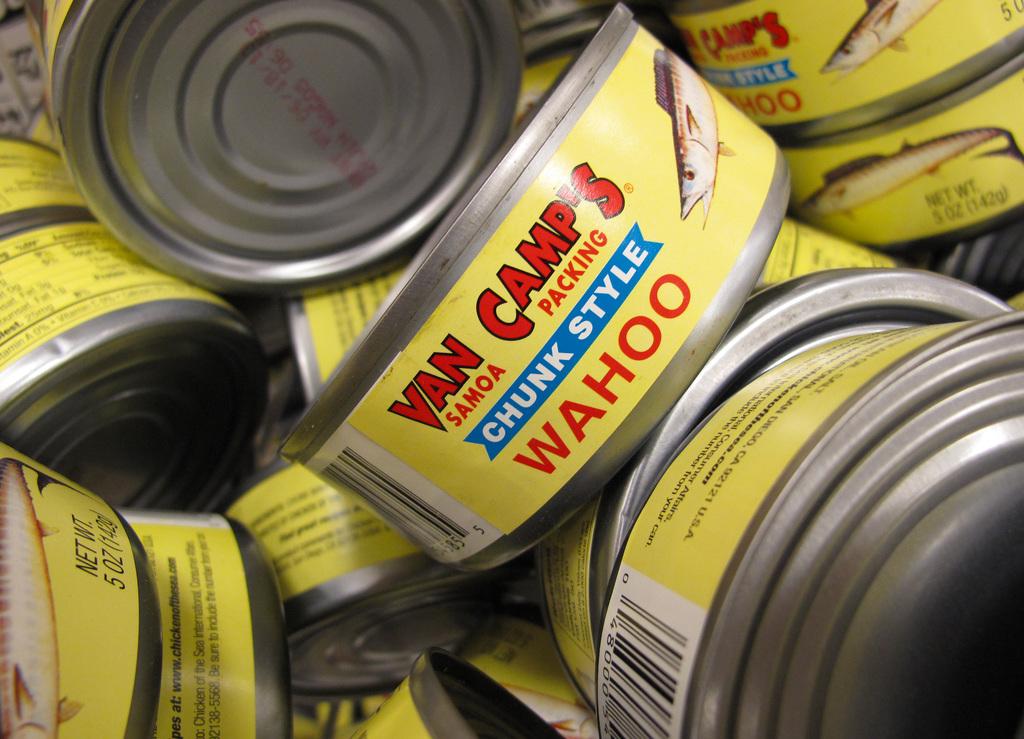What is the brand on the can?
Make the answer very short. Van camps. What does it say in the blue section of the label?
Your response must be concise. Chunk style. 